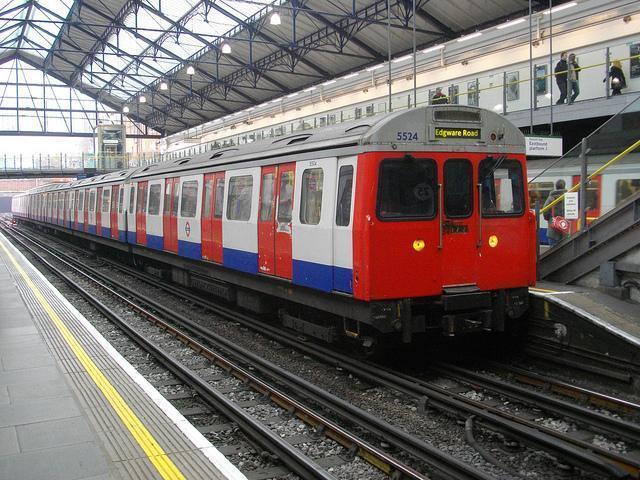How many trains are there?
Give a very brief answer. 2. How many zebras are there?
Give a very brief answer. 0. 